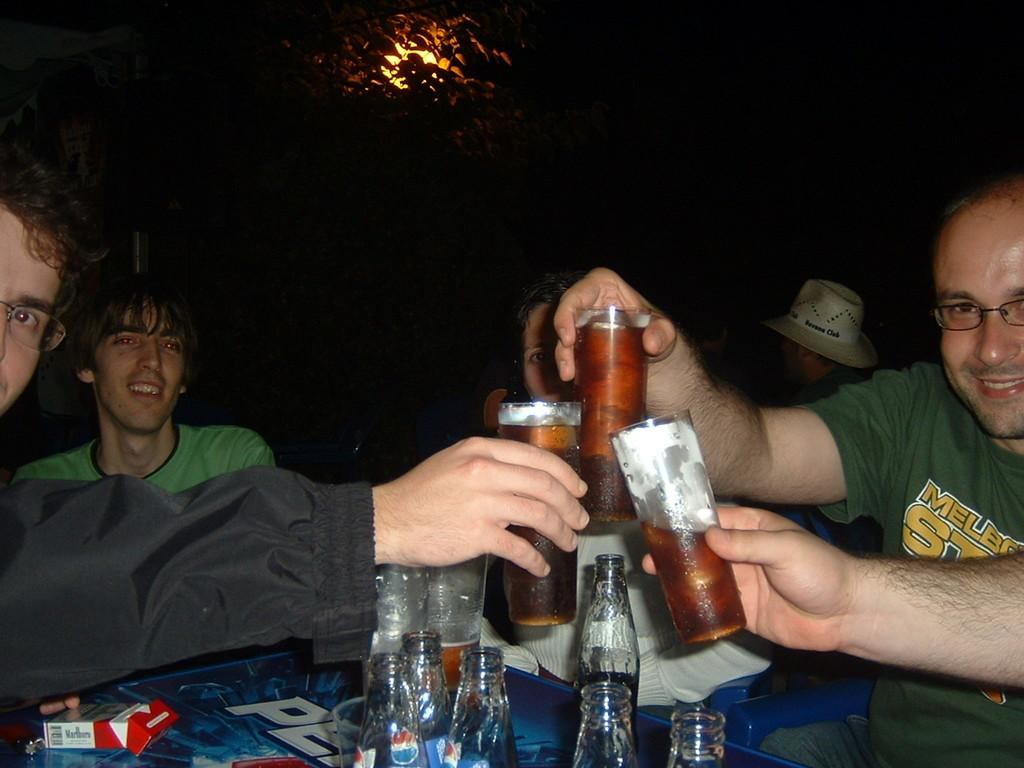<image>
Create a compact narrative representing the image presented. A few friends cheers across a Pepsi table 